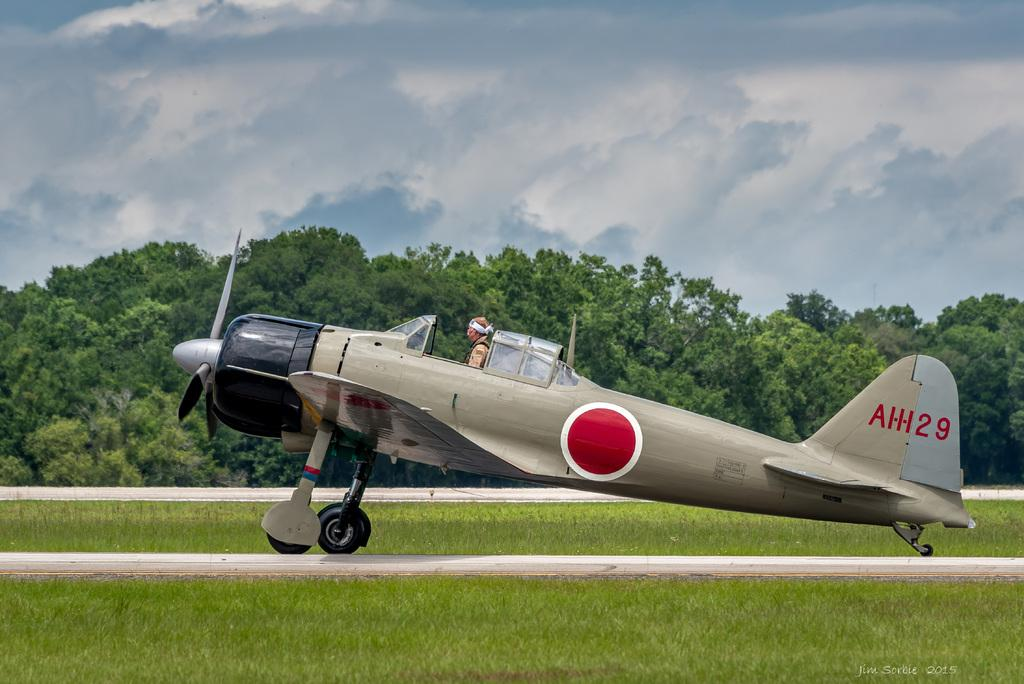What is located in the foreground of the picture? There is a runway, grass, and an aircraft in the foreground of the picture. What type of vegetation is present in the foreground of the picture? There is grass in the foreground of the picture. What is the main subject of the picture? The main subject of the picture is an aircraft. What can be seen in the background of the picture? There are trees in the background of the picture. What is the weather like in the image? The sky is cloudy in the image. Can you tell if there is anyone inside the aircraft? Yes, there is a person inside the aircraft. What type of alarm can be heard going off in the image? There is no alarm present in the image, and therefore no such sound can be heard. Can you see a train in the image? There is no train present in the image. 